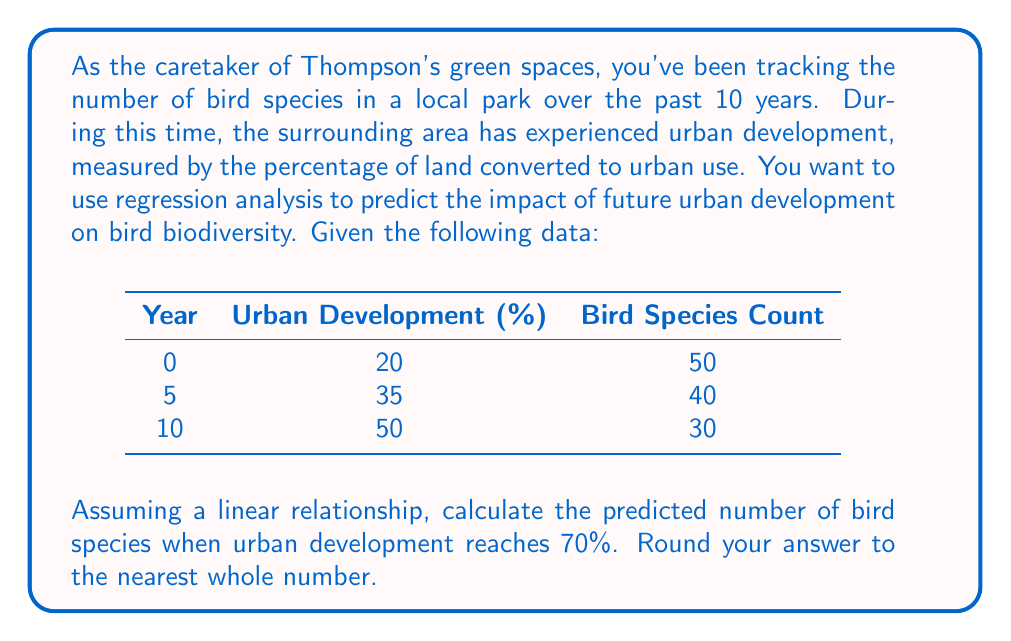Give your solution to this math problem. To solve this problem, we'll use simple linear regression. Let $x$ represent the urban development percentage and $y$ represent the bird species count.

1. First, we need to find the slope $(m)$ and y-intercept $(b)$ of the line $y = mx + b$.

2. The slope can be calculated using the formula:
   $$m = \frac{y_2 - y_1}{x_2 - x_1} = \frac{30 - 50}{50 - 20} = \frac{-20}{30} = -\frac{2}{3}$$

3. Now we can use any point to find the y-intercept:
   $$30 = -\frac{2}{3}(50) + b$$
   $$30 = -33.33 + b$$
   $$b = 63.33$$

4. Our regression equation is:
   $$y = -\frac{2}{3}x + 63.33$$

5. To predict the number of bird species when urban development is 70%, we substitute $x = 70$:
   $$y = -\frac{2}{3}(70) + 63.33$$
   $$y = -46.67 + 63.33 = 16.66$$

6. Rounding to the nearest whole number:
   $$y \approx 17$$
Answer: 17 bird species 